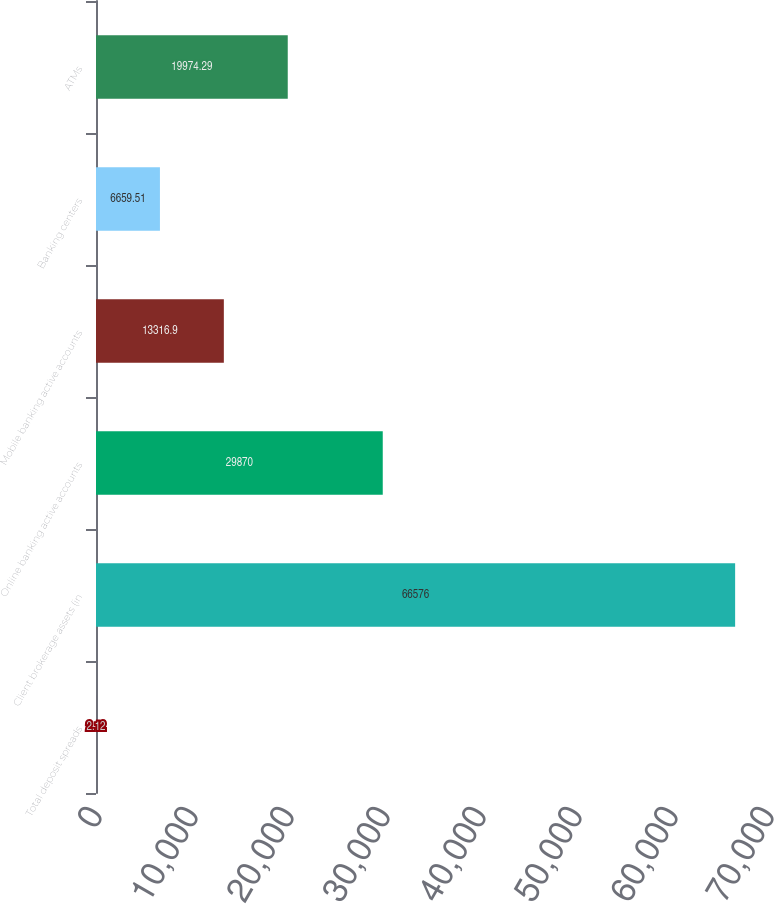Convert chart to OTSL. <chart><loc_0><loc_0><loc_500><loc_500><bar_chart><fcel>Total deposit spreads<fcel>Client brokerage assets (in<fcel>Online banking active accounts<fcel>Mobile banking active accounts<fcel>Banking centers<fcel>ATMs<nl><fcel>2.12<fcel>66576<fcel>29870<fcel>13316.9<fcel>6659.51<fcel>19974.3<nl></chart> 